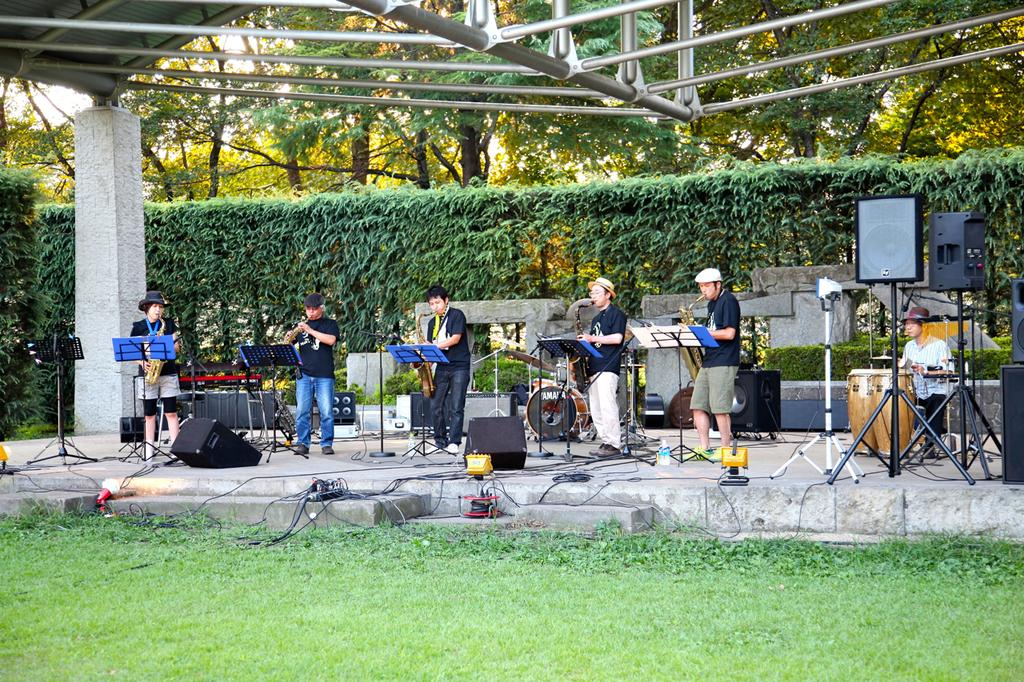What are the people in the image doing? The people in the image are standing and holding musical instruments. What can be seen in the background of the image? There are trees and the sky visible in the background of the image. What type of mint can be seen growing near the trees in the image? There is no mint visible in the image; only trees are mentioned in the background. 